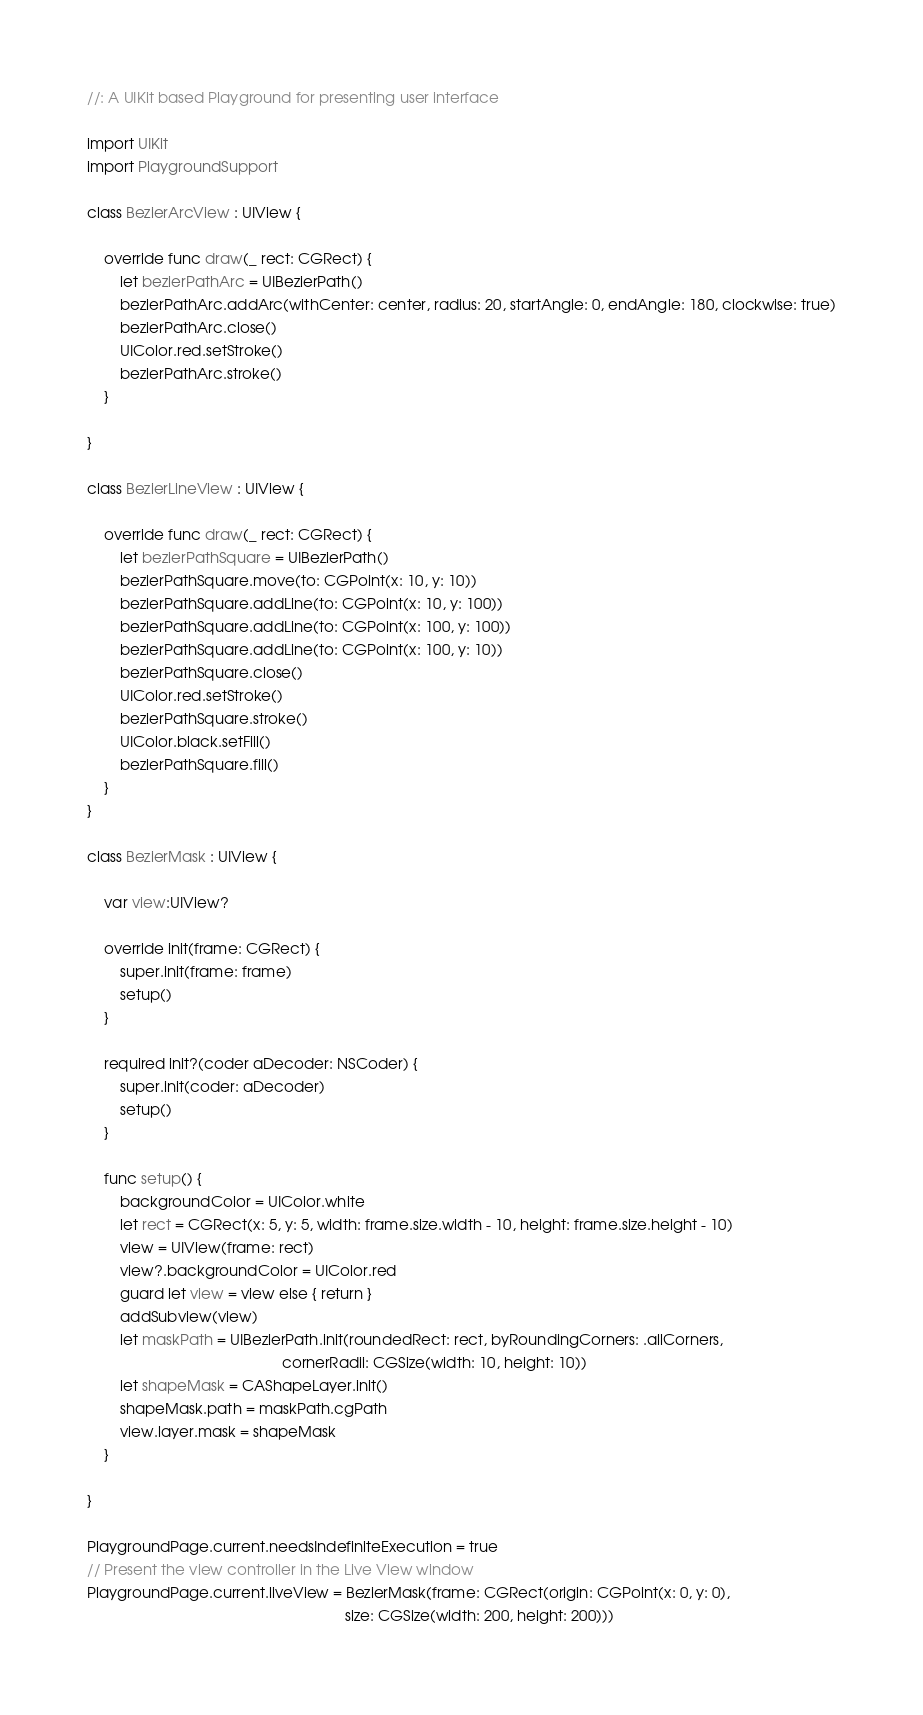<code> <loc_0><loc_0><loc_500><loc_500><_Swift_>//: A UIKit based Playground for presenting user interface
  
import UIKit
import PlaygroundSupport

class BezierArcView : UIView {
    
    override func draw(_ rect: CGRect) {
        let bezierPathArc = UIBezierPath()
        bezierPathArc.addArc(withCenter: center, radius: 20, startAngle: 0, endAngle: 180, clockwise: true)
        bezierPathArc.close()
        UIColor.red.setStroke()
        bezierPathArc.stroke()
    }
    
}

class BezierLineView : UIView {
    
    override func draw(_ rect: CGRect) {
        let bezierPathSquare = UIBezierPath()
        bezierPathSquare.move(to: CGPoint(x: 10, y: 10))
        bezierPathSquare.addLine(to: CGPoint(x: 10, y: 100))
        bezierPathSquare.addLine(to: CGPoint(x: 100, y: 100))
        bezierPathSquare.addLine(to: CGPoint(x: 100, y: 10))
        bezierPathSquare.close()
        UIColor.red.setStroke()
        bezierPathSquare.stroke()
        UIColor.black.setFill()
        bezierPathSquare.fill()
    }
}

class BezierMask : UIView {
    
    var view:UIView?
    
    override init(frame: CGRect) {
        super.init(frame: frame)
        setup()
    }
    
    required init?(coder aDecoder: NSCoder) {
        super.init(coder: aDecoder)
        setup()
    }
    
    func setup() {
        backgroundColor = UIColor.white
        let rect = CGRect(x: 5, y: 5, width: frame.size.width - 10, height: frame.size.height - 10)
        view = UIView(frame: rect)
        view?.backgroundColor = UIColor.red
        guard let view = view else { return }
        addSubview(view)
        let maskPath = UIBezierPath.init(roundedRect: rect, byRoundingCorners: .allCorners,
                                               cornerRadii: CGSize(width: 10, height: 10))
        let shapeMask = CAShapeLayer.init()
        shapeMask.path = maskPath.cgPath
        view.layer.mask = shapeMask
    }
    
}

PlaygroundPage.current.needsIndefiniteExecution = true
// Present the view controller in the Live View window
PlaygroundPage.current.liveView = BezierMask(frame: CGRect(origin: CGPoint(x: 0, y: 0),
                                                              size: CGSize(width: 200, height: 200)))
</code> 